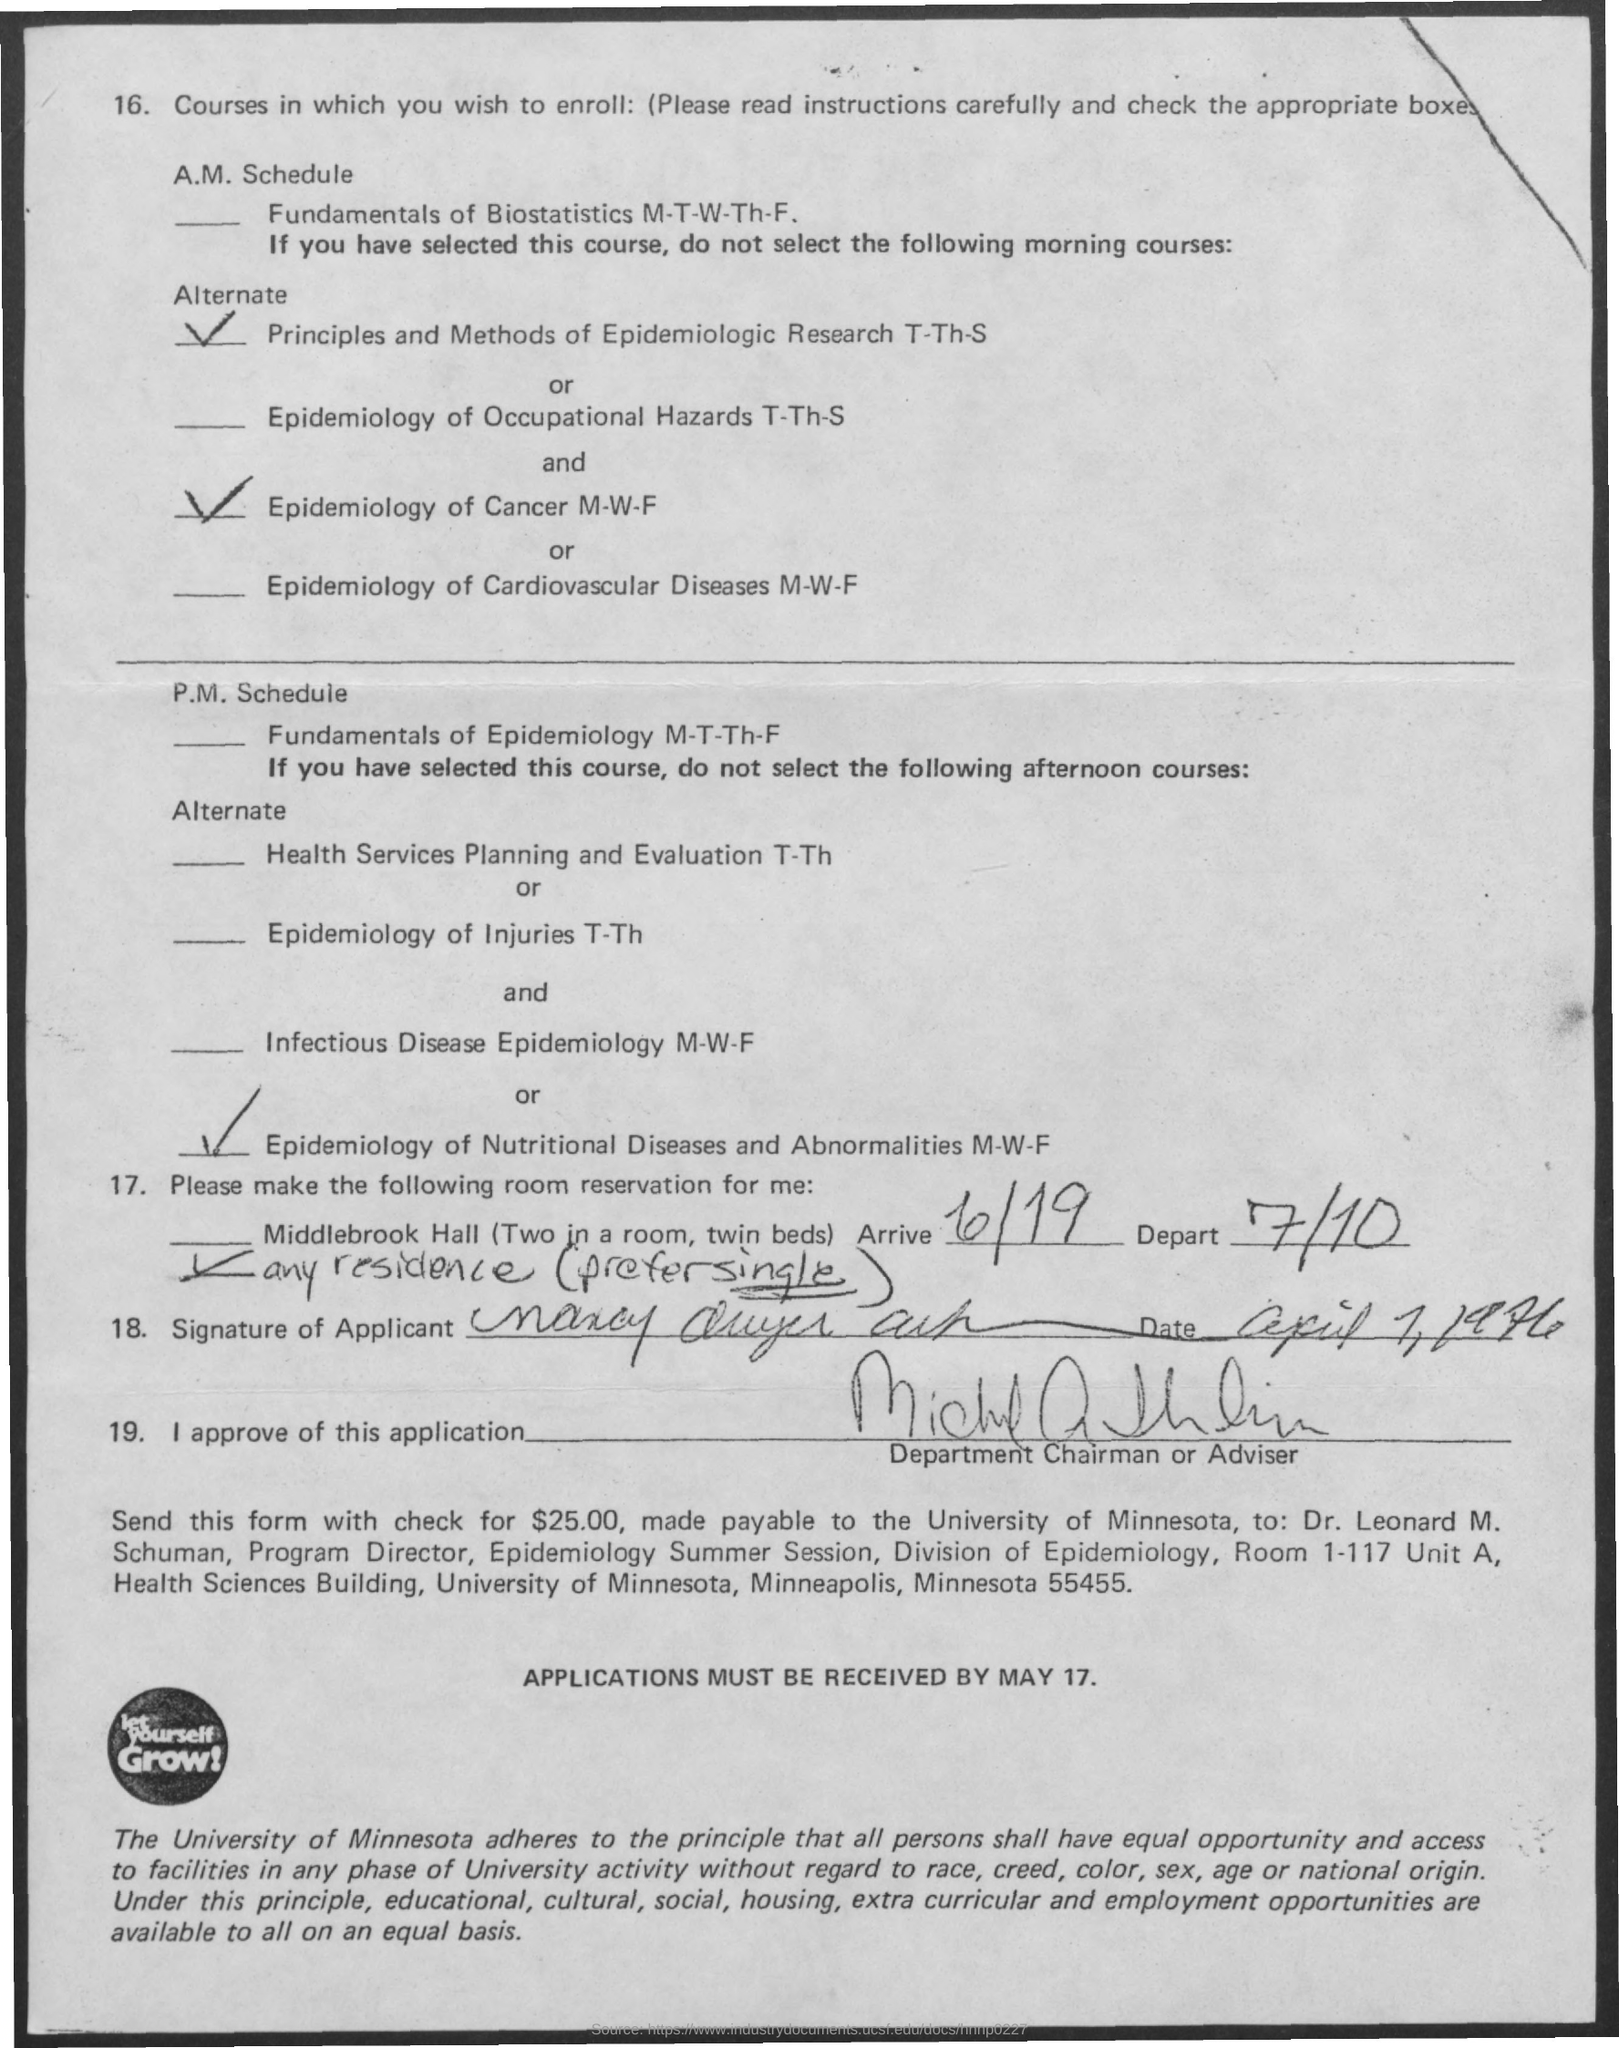Mention a couple of crucial points in this snapshot. The program director is Dr. Leonard M. Schuman. The applications must be received by May 17th. The total amount to be paid is $25.00, which must be paid in the form of a check. The name of the university is the University of Minnesota. The depart date is on July 10. 